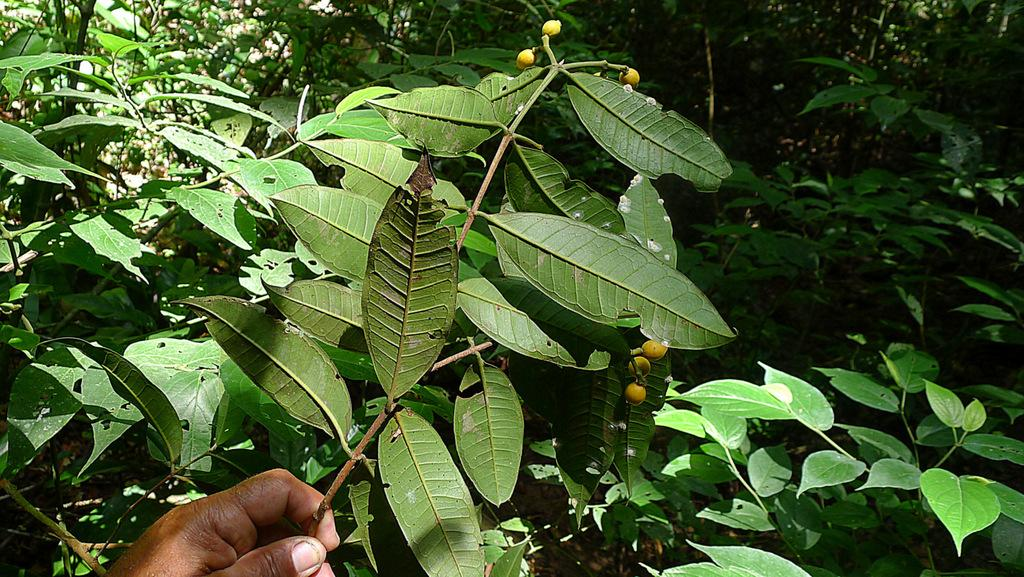Who or what is present in the image? There is a person in the image. What is the person holding in the image? The person's hand is holding a plant. What can be seen in the background of the image? There are trees in the background of the image. What type of vegetable is the owl eating in the image? There is no owl or vegetable present in the image. 